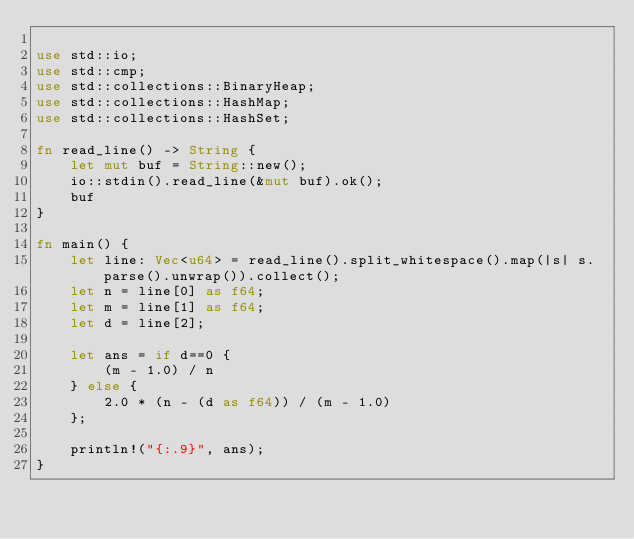Convert code to text. <code><loc_0><loc_0><loc_500><loc_500><_Rust_>
use std::io;
use std::cmp;
use std::collections::BinaryHeap;
use std::collections::HashMap;
use std::collections::HashSet;

fn read_line() -> String {
    let mut buf = String::new();
    io::stdin().read_line(&mut buf).ok();
    buf
}

fn main() {
    let line: Vec<u64> = read_line().split_whitespace().map(|s| s.parse().unwrap()).collect();
    let n = line[0] as f64;
    let m = line[1] as f64;
    let d = line[2];

    let ans = if d==0 {
        (m - 1.0) / n
    } else {
        2.0 * (n - (d as f64)) / (m - 1.0)
    };

    println!("{:.9}", ans);
}
</code> 